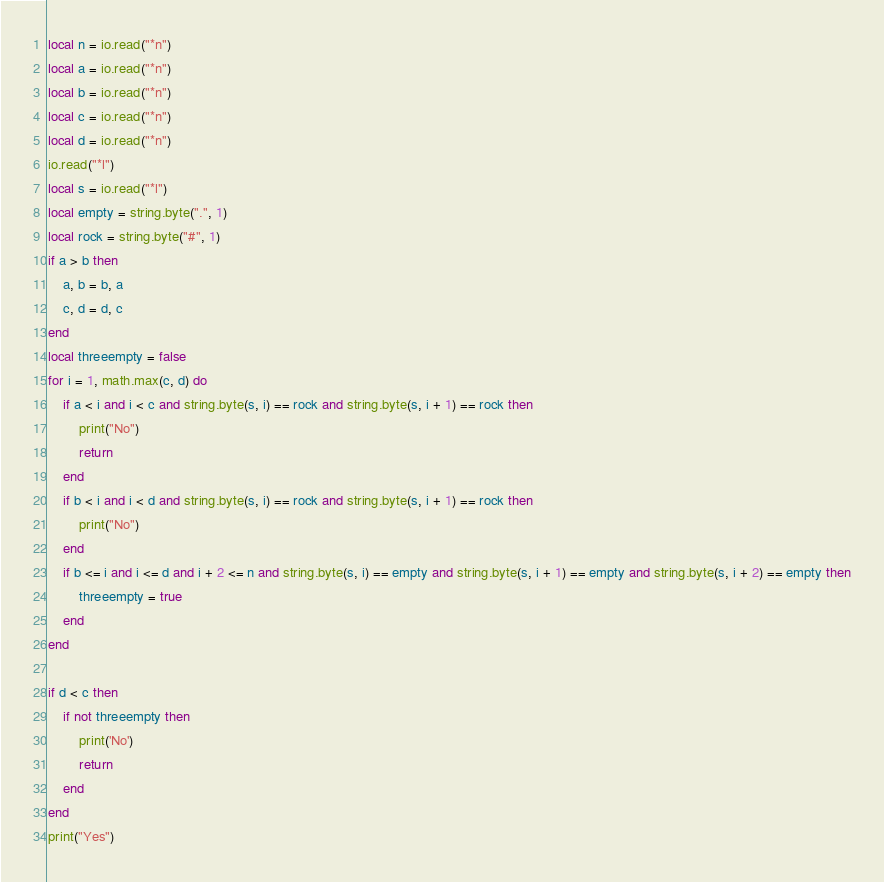Convert code to text. <code><loc_0><loc_0><loc_500><loc_500><_Lua_>local n = io.read("*n")
local a = io.read("*n")
local b = io.read("*n")
local c = io.read("*n")
local d = io.read("*n")
io.read("*l")
local s = io.read("*l")
local empty = string.byte(".", 1)
local rock = string.byte("#", 1)
if a > b then
	a, b = b, a
	c, d = d, c
end
local threeempty = false
for i = 1, math.max(c, d) do 
	if a < i and i < c and string.byte(s, i) == rock and string.byte(s, i + 1) == rock then
		print("No")
		return
	end
	if b < i and i < d and string.byte(s, i) == rock and string.byte(s, i + 1) == rock then
		print("No")
	end
	if b <= i and i <= d and i + 2 <= n and string.byte(s, i) == empty and string.byte(s, i + 1) == empty and string.byte(s, i + 2) == empty then
		threeempty = true
	end
end

if d < c then
	if not threeempty then
		print('No')
		return
	end
end
print("Yes")</code> 